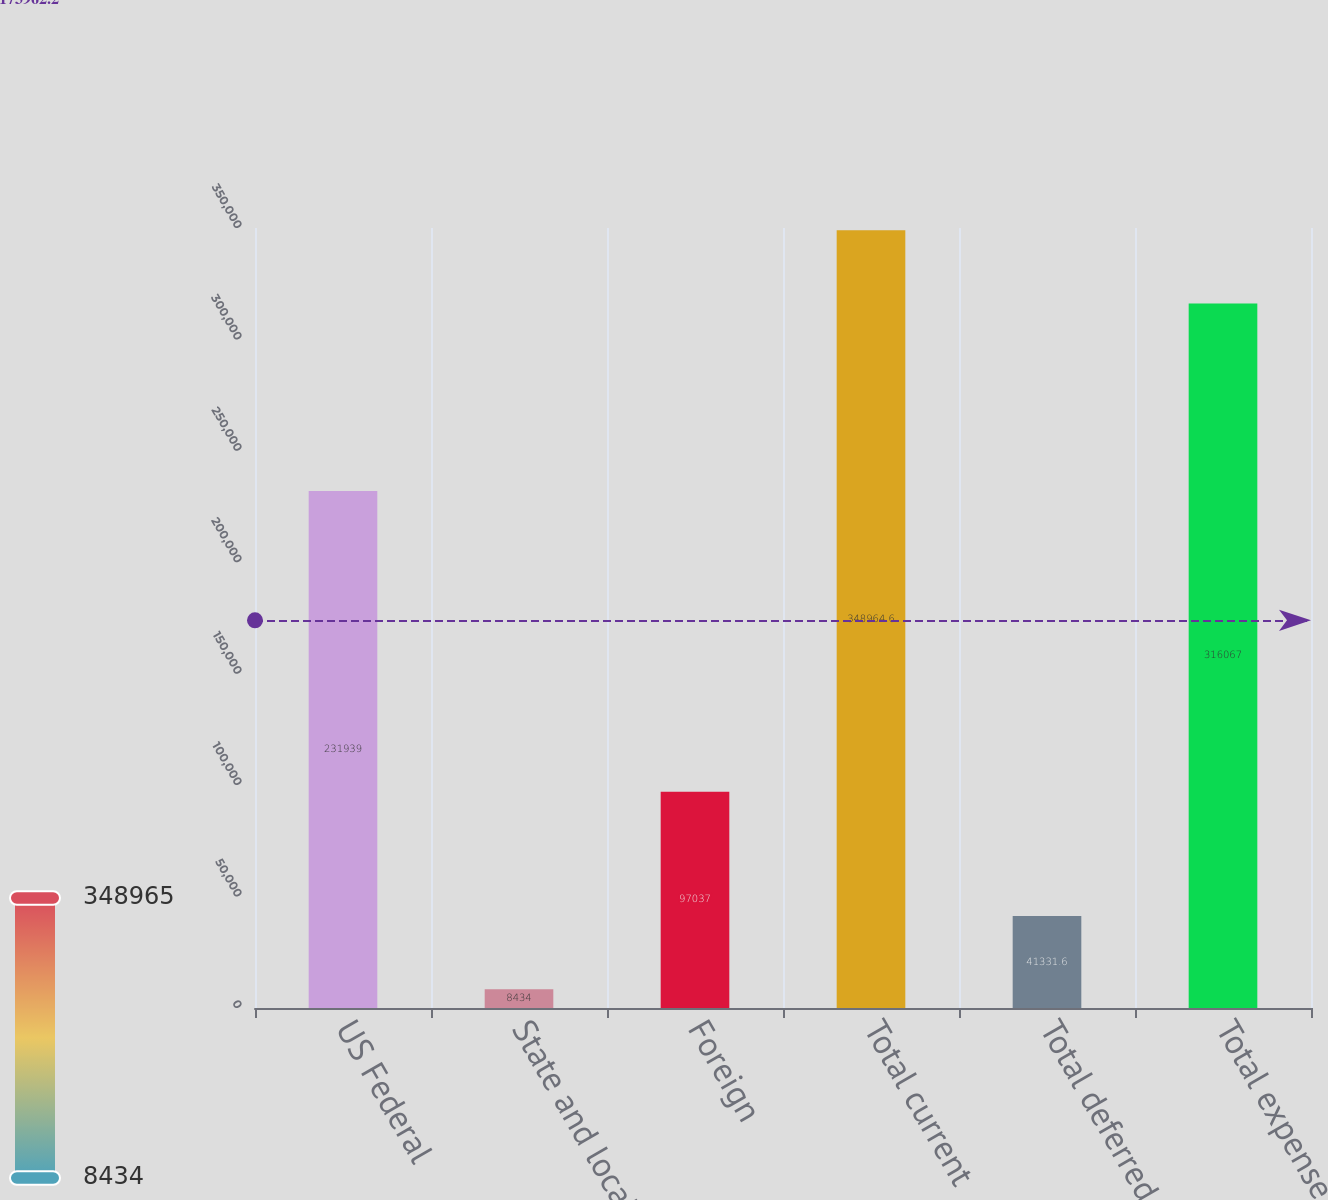Convert chart to OTSL. <chart><loc_0><loc_0><loc_500><loc_500><bar_chart><fcel>US Federal<fcel>State and local<fcel>Foreign<fcel>Total current<fcel>Total deferred<fcel>Total expense<nl><fcel>231939<fcel>8434<fcel>97037<fcel>348965<fcel>41331.6<fcel>316067<nl></chart> 